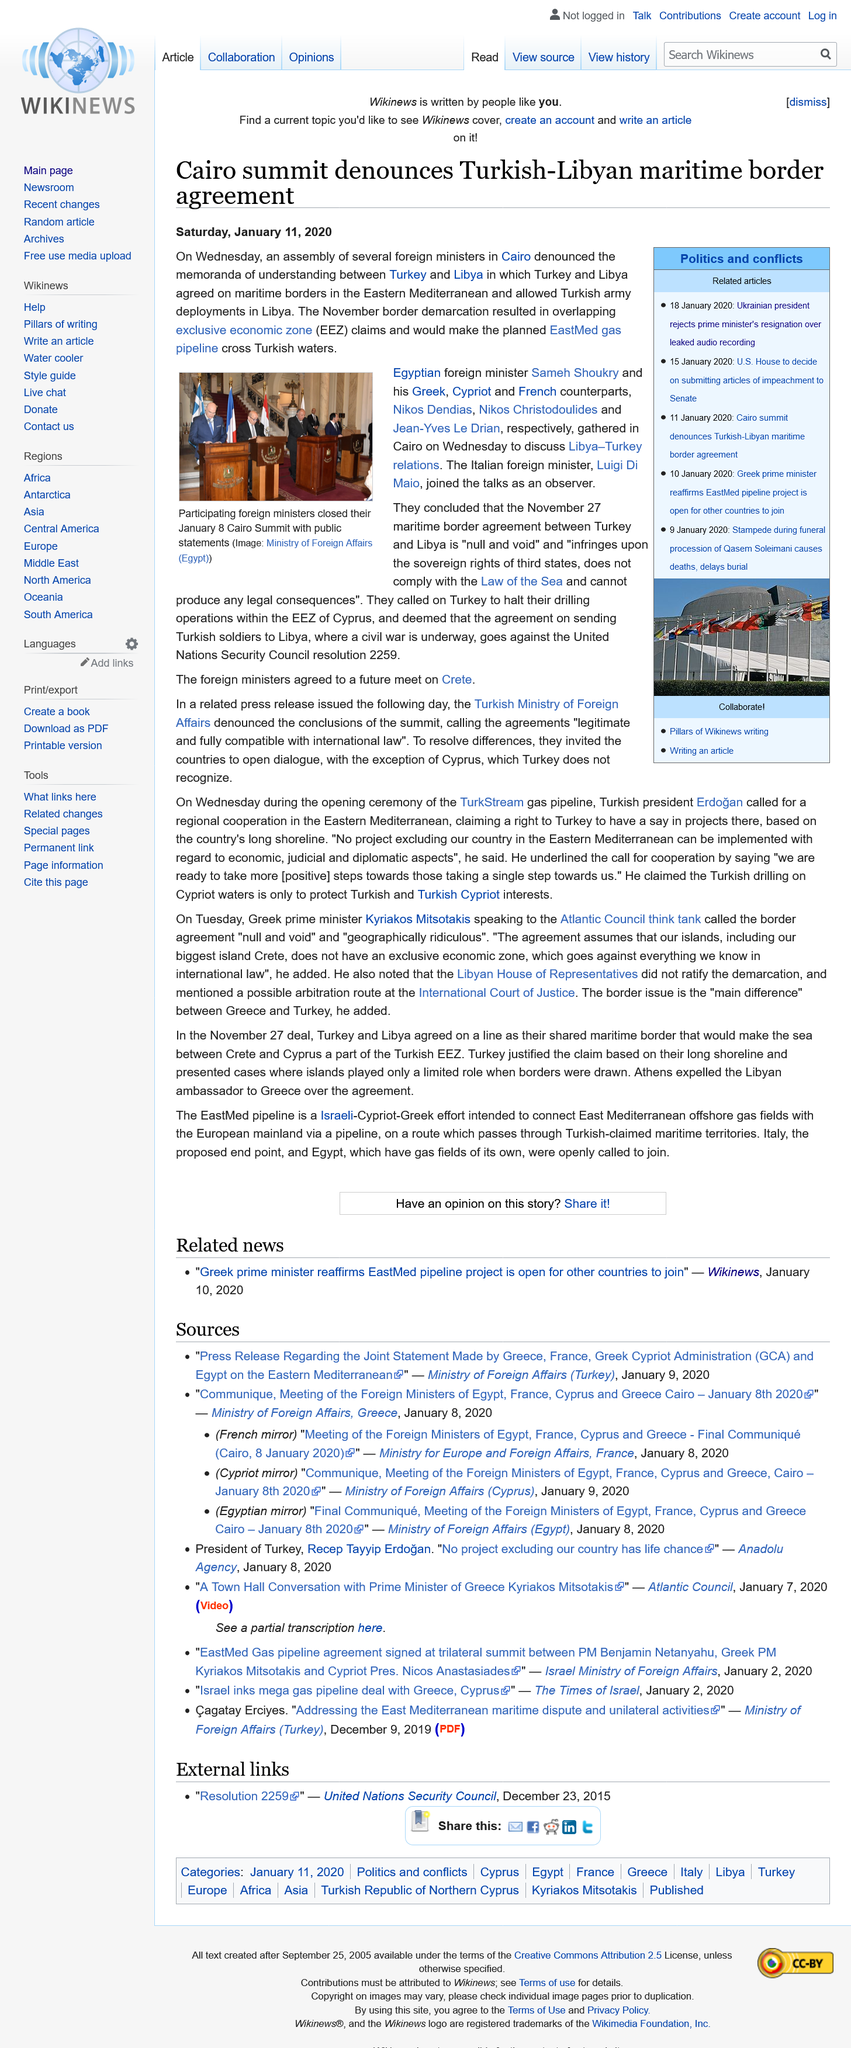Identify some key points in this picture. Exclusive Economic Zone" is a term commonly referred to as EEZ. The Cairo summit denounced the Turkish-Libyan maritime border agreement on Wednesday, January 8, 2020. The resignation of the Ukrainian Prime Minister was caused by a leaked audio recording. 